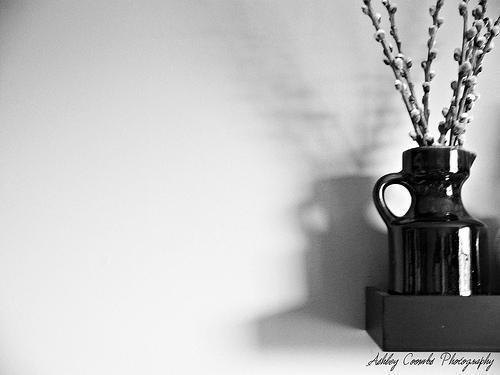How many vases are in the photo?
Give a very brief answer. 1. 